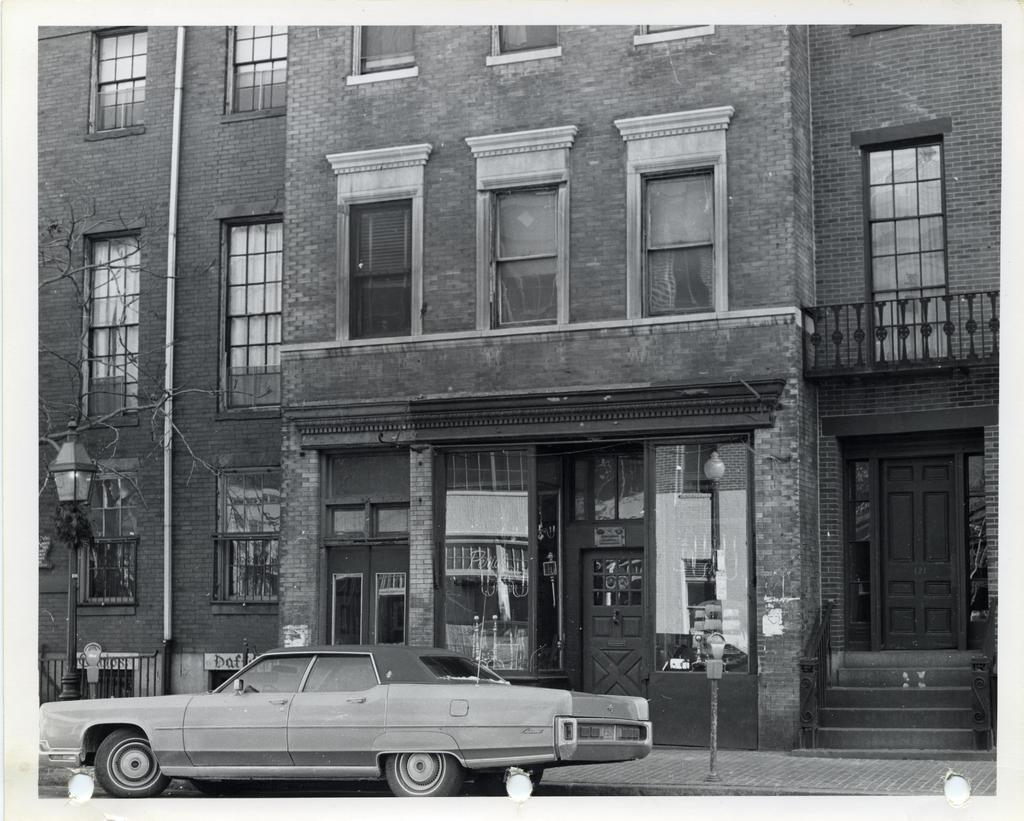How would you summarize this image in a sentence or two? In the picture we can see a black and white photograph of a part if the building with many windows and door near it, we can see two poles with lamps and near it we can see a vintage car is parked. 